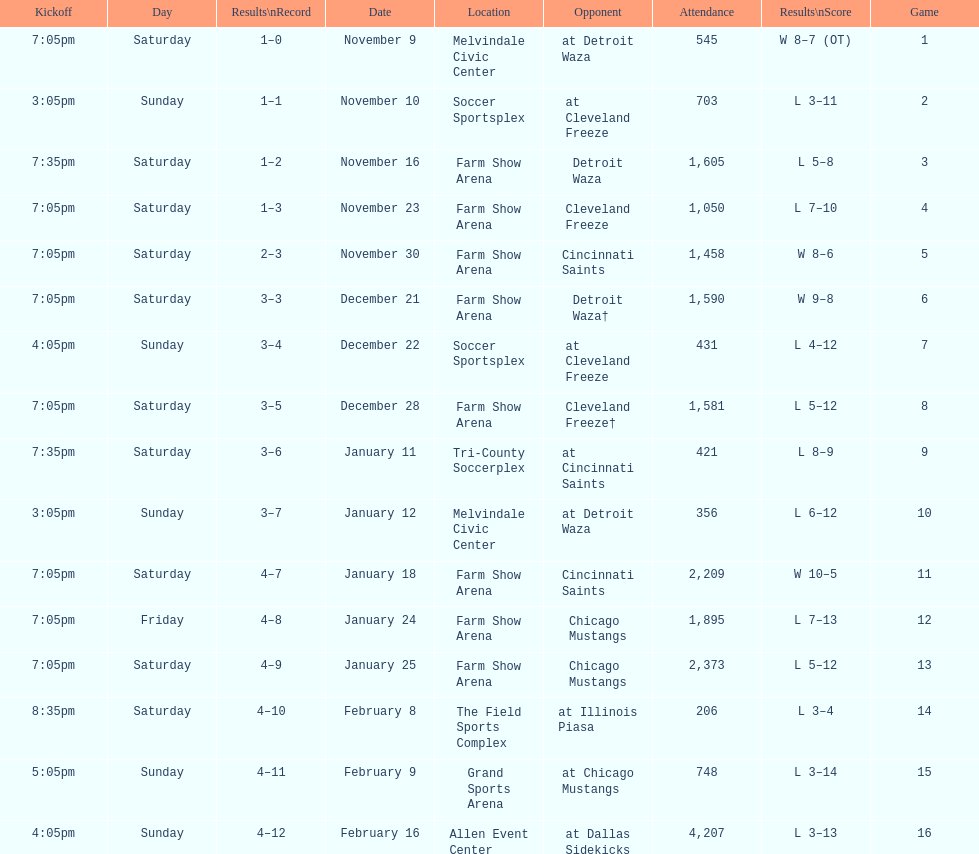Would you be able to parse every entry in this table? {'header': ['Kickoff', 'Day', 'Results\\nRecord', 'Date', 'Location', 'Opponent', 'Attendance', 'Results\\nScore', 'Game'], 'rows': [['7:05pm', 'Saturday', '1–0', 'November 9', 'Melvindale Civic Center', 'at Detroit Waza', '545', 'W 8–7 (OT)', '1'], ['3:05pm', 'Sunday', '1–1', 'November 10', 'Soccer Sportsplex', 'at Cleveland Freeze', '703', 'L 3–11', '2'], ['7:35pm', 'Saturday', '1–2', 'November 16', 'Farm Show Arena', 'Detroit Waza', '1,605', 'L 5–8', '3'], ['7:05pm', 'Saturday', '1–3', 'November 23', 'Farm Show Arena', 'Cleveland Freeze', '1,050', 'L 7–10', '4'], ['7:05pm', 'Saturday', '2–3', 'November 30', 'Farm Show Arena', 'Cincinnati Saints', '1,458', 'W 8–6', '5'], ['7:05pm', 'Saturday', '3–3', 'December 21', 'Farm Show Arena', 'Detroit Waza†', '1,590', 'W 9–8', '6'], ['4:05pm', 'Sunday', '3–4', 'December 22', 'Soccer Sportsplex', 'at Cleveland Freeze', '431', 'L 4–12', '7'], ['7:05pm', 'Saturday', '3–5', 'December 28', 'Farm Show Arena', 'Cleveland Freeze†', '1,581', 'L 5–12', '8'], ['7:35pm', 'Saturday', '3–6', 'January 11', 'Tri-County Soccerplex', 'at Cincinnati Saints', '421', 'L 8–9', '9'], ['3:05pm', 'Sunday', '3–7', 'January 12', 'Melvindale Civic Center', 'at Detroit Waza', '356', 'L 6–12', '10'], ['7:05pm', 'Saturday', '4–7', 'January 18', 'Farm Show Arena', 'Cincinnati Saints', '2,209', 'W 10–5', '11'], ['7:05pm', 'Friday', '4–8', 'January 24', 'Farm Show Arena', 'Chicago Mustangs', '1,895', 'L 7–13', '12'], ['7:05pm', 'Saturday', '4–9', 'January 25', 'Farm Show Arena', 'Chicago Mustangs', '2,373', 'L 5–12', '13'], ['8:35pm', 'Saturday', '4–10', 'February 8', 'The Field Sports Complex', 'at Illinois Piasa', '206', 'L 3–4', '14'], ['5:05pm', 'Sunday', '4–11', 'February 9', 'Grand Sports Arena', 'at Chicago Mustangs', '748', 'L 3–14', '15'], ['4:05pm', 'Sunday', '4–12', 'February 16', 'Allen Event Center', 'at Dallas Sidekicks', '4,207', 'L 3–13', '16']]} Which opponent is listed first in the table? Detroit Waza. 